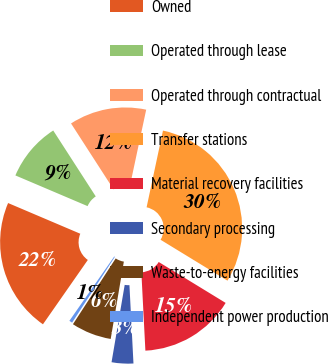Convert chart. <chart><loc_0><loc_0><loc_500><loc_500><pie_chart><fcel>Owned<fcel>Operated through lease<fcel>Operated through contractual<fcel>Transfer stations<fcel>Material recovery facilities<fcel>Secondary processing<fcel>Waste-to-energy facilities<fcel>Independent power production<nl><fcel>21.71%<fcel>9.48%<fcel>12.47%<fcel>30.39%<fcel>15.45%<fcel>3.5%<fcel>6.49%<fcel>0.52%<nl></chart> 